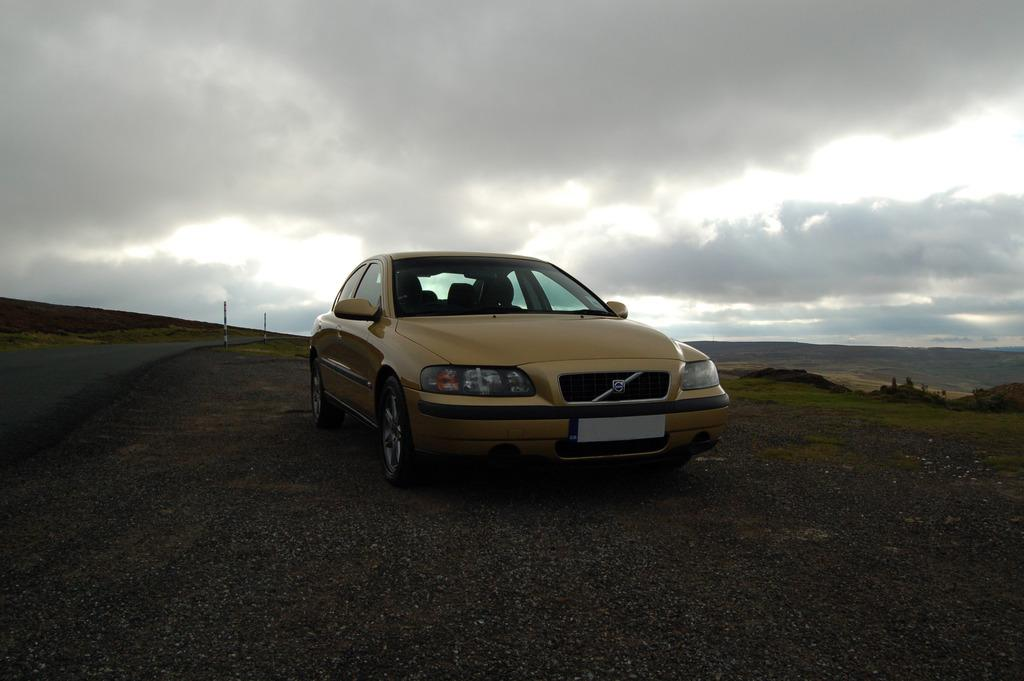What is the main subject of the image? There is a car on the road in the image. What else can be seen in the image besides the car? There are poles visible in the image. What is visible in the background of the image? The sky is visible in the image. How would you describe the weather based on the appearance of the sky? The sky appears to be cloudy in the image. What type of celery is being used to clean the car in the image? There is no celery present in the image, and therefore no such activity can be observed. 